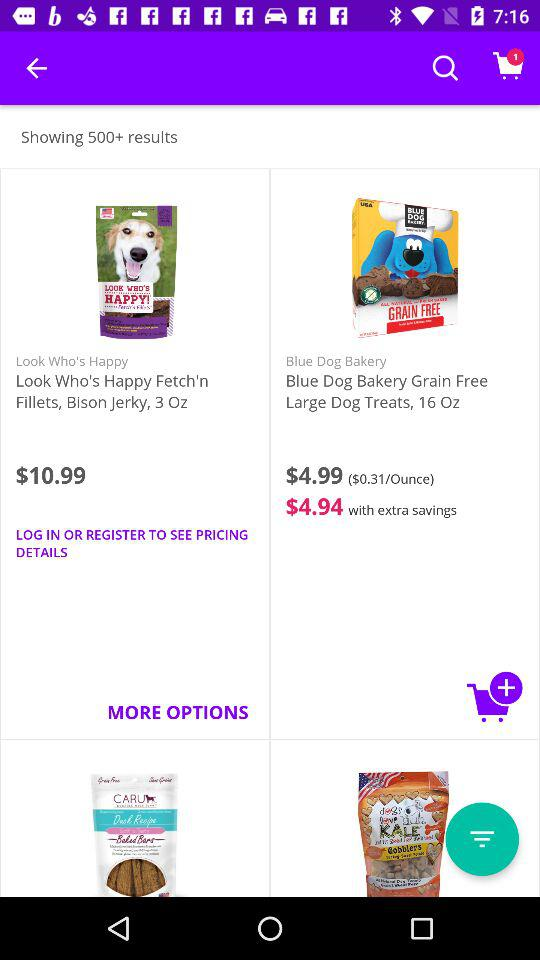What is the price of "Look Who's Happy Fetch'n"? The price is $10.99. 